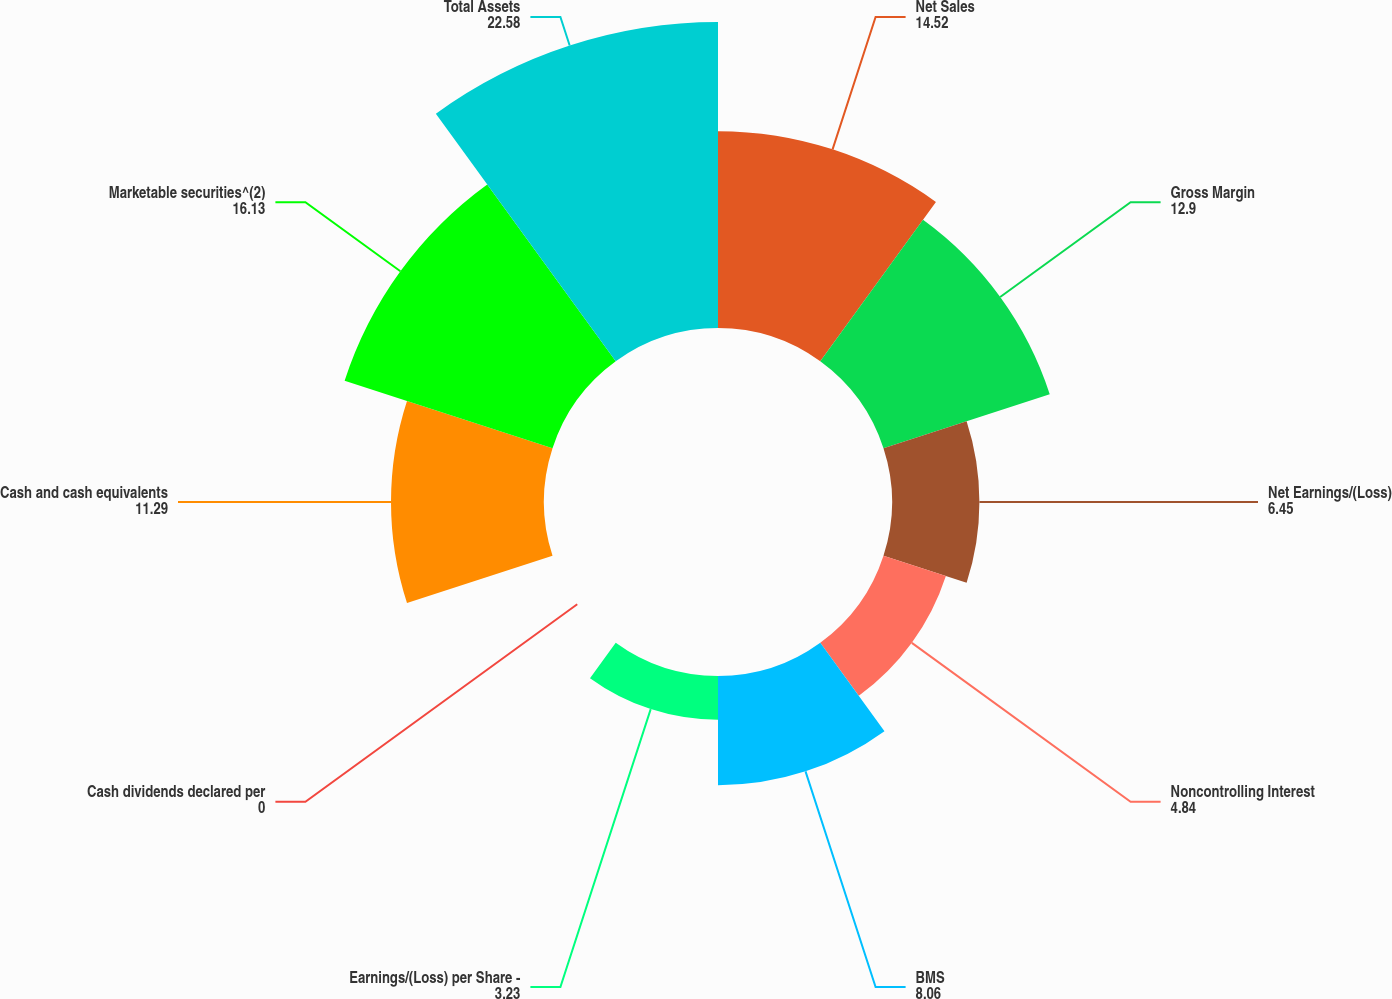Convert chart to OTSL. <chart><loc_0><loc_0><loc_500><loc_500><pie_chart><fcel>Net Sales<fcel>Gross Margin<fcel>Net Earnings/(Loss)<fcel>Noncontrolling Interest<fcel>BMS<fcel>Earnings/(Loss) per Share -<fcel>Cash dividends declared per<fcel>Cash and cash equivalents<fcel>Marketable securities^(2)<fcel>Total Assets<nl><fcel>14.52%<fcel>12.9%<fcel>6.45%<fcel>4.84%<fcel>8.06%<fcel>3.23%<fcel>0.0%<fcel>11.29%<fcel>16.13%<fcel>22.58%<nl></chart> 